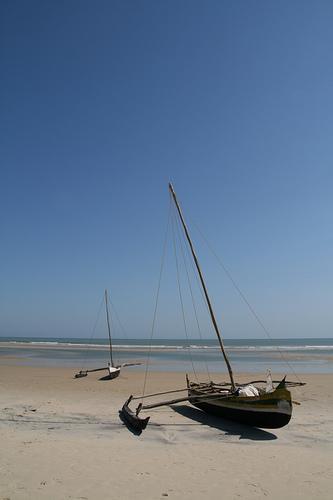How many boats are there?
Give a very brief answer. 2. How many people are on the boat?
Give a very brief answer. 0. How many boats can you see?
Give a very brief answer. 2. 